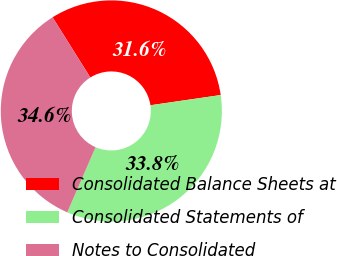<chart> <loc_0><loc_0><loc_500><loc_500><pie_chart><fcel>Consolidated Balance Sheets at<fcel>Consolidated Statements of<fcel>Notes to Consolidated<nl><fcel>31.62%<fcel>33.82%<fcel>34.56%<nl></chart> 